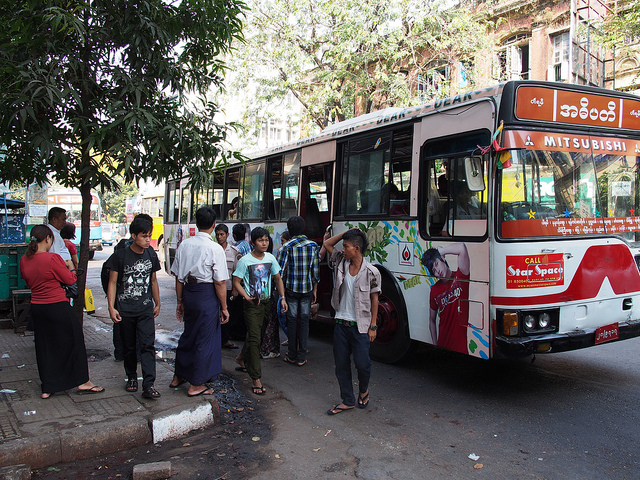Please extract the text content from this image. CALL mitsubishi Space Star DEAN 